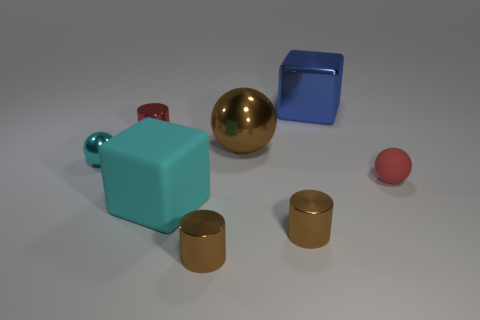Add 1 tiny cyan cubes. How many objects exist? 9 Subtract all balls. How many objects are left? 5 Subtract 0 cyan cylinders. How many objects are left? 8 Subtract all small gray shiny balls. Subtract all blue metal objects. How many objects are left? 7 Add 8 small cyan metal objects. How many small cyan metal objects are left? 9 Add 7 small blue rubber cubes. How many small blue rubber cubes exist? 7 